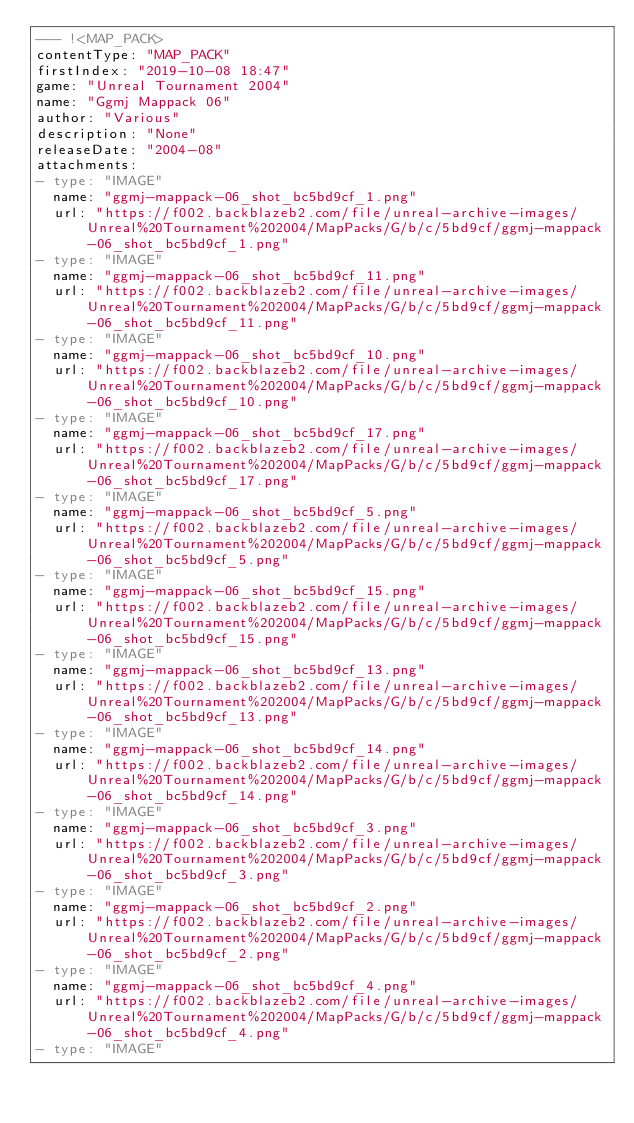<code> <loc_0><loc_0><loc_500><loc_500><_YAML_>--- !<MAP_PACK>
contentType: "MAP_PACK"
firstIndex: "2019-10-08 18:47"
game: "Unreal Tournament 2004"
name: "Ggmj Mappack 06"
author: "Various"
description: "None"
releaseDate: "2004-08"
attachments:
- type: "IMAGE"
  name: "ggmj-mappack-06_shot_bc5bd9cf_1.png"
  url: "https://f002.backblazeb2.com/file/unreal-archive-images/Unreal%20Tournament%202004/MapPacks/G/b/c/5bd9cf/ggmj-mappack-06_shot_bc5bd9cf_1.png"
- type: "IMAGE"
  name: "ggmj-mappack-06_shot_bc5bd9cf_11.png"
  url: "https://f002.backblazeb2.com/file/unreal-archive-images/Unreal%20Tournament%202004/MapPacks/G/b/c/5bd9cf/ggmj-mappack-06_shot_bc5bd9cf_11.png"
- type: "IMAGE"
  name: "ggmj-mappack-06_shot_bc5bd9cf_10.png"
  url: "https://f002.backblazeb2.com/file/unreal-archive-images/Unreal%20Tournament%202004/MapPacks/G/b/c/5bd9cf/ggmj-mappack-06_shot_bc5bd9cf_10.png"
- type: "IMAGE"
  name: "ggmj-mappack-06_shot_bc5bd9cf_17.png"
  url: "https://f002.backblazeb2.com/file/unreal-archive-images/Unreal%20Tournament%202004/MapPacks/G/b/c/5bd9cf/ggmj-mappack-06_shot_bc5bd9cf_17.png"
- type: "IMAGE"
  name: "ggmj-mappack-06_shot_bc5bd9cf_5.png"
  url: "https://f002.backblazeb2.com/file/unreal-archive-images/Unreal%20Tournament%202004/MapPacks/G/b/c/5bd9cf/ggmj-mappack-06_shot_bc5bd9cf_5.png"
- type: "IMAGE"
  name: "ggmj-mappack-06_shot_bc5bd9cf_15.png"
  url: "https://f002.backblazeb2.com/file/unreal-archive-images/Unreal%20Tournament%202004/MapPacks/G/b/c/5bd9cf/ggmj-mappack-06_shot_bc5bd9cf_15.png"
- type: "IMAGE"
  name: "ggmj-mappack-06_shot_bc5bd9cf_13.png"
  url: "https://f002.backblazeb2.com/file/unreal-archive-images/Unreal%20Tournament%202004/MapPacks/G/b/c/5bd9cf/ggmj-mappack-06_shot_bc5bd9cf_13.png"
- type: "IMAGE"
  name: "ggmj-mappack-06_shot_bc5bd9cf_14.png"
  url: "https://f002.backblazeb2.com/file/unreal-archive-images/Unreal%20Tournament%202004/MapPacks/G/b/c/5bd9cf/ggmj-mappack-06_shot_bc5bd9cf_14.png"
- type: "IMAGE"
  name: "ggmj-mappack-06_shot_bc5bd9cf_3.png"
  url: "https://f002.backblazeb2.com/file/unreal-archive-images/Unreal%20Tournament%202004/MapPacks/G/b/c/5bd9cf/ggmj-mappack-06_shot_bc5bd9cf_3.png"
- type: "IMAGE"
  name: "ggmj-mappack-06_shot_bc5bd9cf_2.png"
  url: "https://f002.backblazeb2.com/file/unreal-archive-images/Unreal%20Tournament%202004/MapPacks/G/b/c/5bd9cf/ggmj-mappack-06_shot_bc5bd9cf_2.png"
- type: "IMAGE"
  name: "ggmj-mappack-06_shot_bc5bd9cf_4.png"
  url: "https://f002.backblazeb2.com/file/unreal-archive-images/Unreal%20Tournament%202004/MapPacks/G/b/c/5bd9cf/ggmj-mappack-06_shot_bc5bd9cf_4.png"
- type: "IMAGE"</code> 